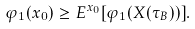Convert formula to latex. <formula><loc_0><loc_0><loc_500><loc_500>\varphi _ { 1 } ( x _ { 0 } ) \geq E ^ { x _ { 0 } } [ \varphi _ { 1 } ( X ( \tau _ { B } ) ) ] .</formula> 